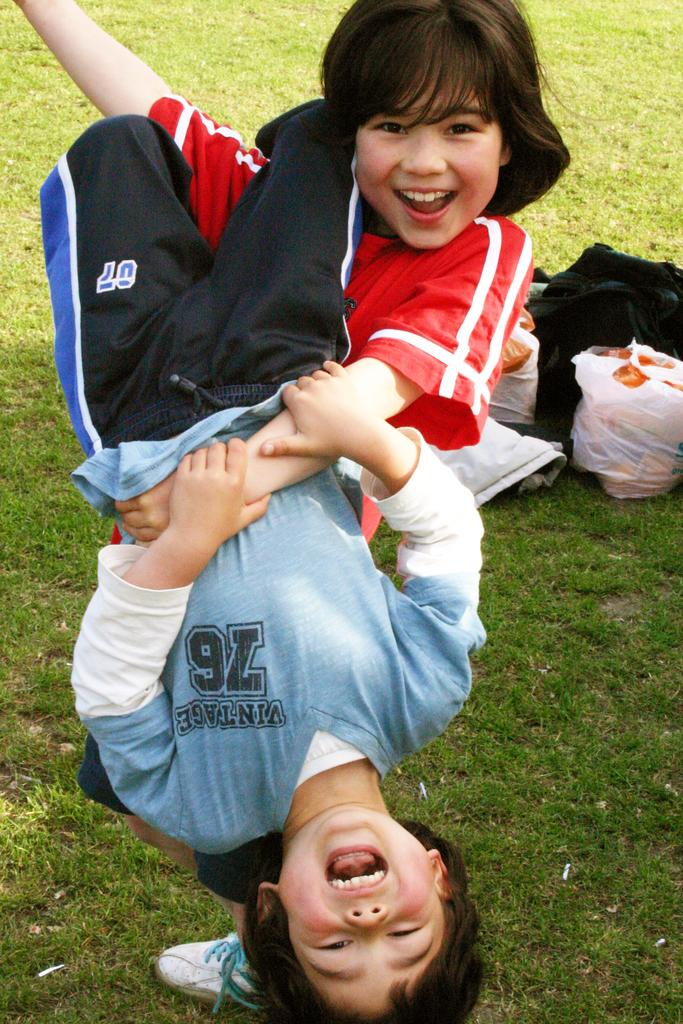How many people are present in the image? There are two people in the image. What is the facial expression of the people in the image? The people are smiling. What can be seen in the background of the image? There are plastic covers, a bag, and cloth on the grass in the background of the image. Where are the kittens playing in the image? There are no kittens present in the image. Can you see a stream in the background of the image? There is no stream visible in the image. 